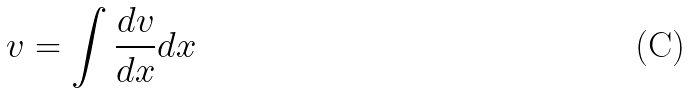<formula> <loc_0><loc_0><loc_500><loc_500>v = \int \frac { d v } { d x } d x</formula> 